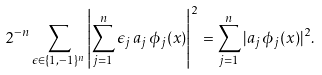<formula> <loc_0><loc_0><loc_500><loc_500>2 ^ { - n } \sum _ { \epsilon \in \{ 1 , - 1 \} ^ { n } } \left | \sum _ { j = 1 } ^ { n } \epsilon _ { j } \, a _ { j } \, \phi _ { j } ( x ) \right | ^ { 2 } = \sum _ { j = 1 } ^ { n } | a _ { j } \, \phi _ { j } ( x ) | ^ { 2 } .</formula> 